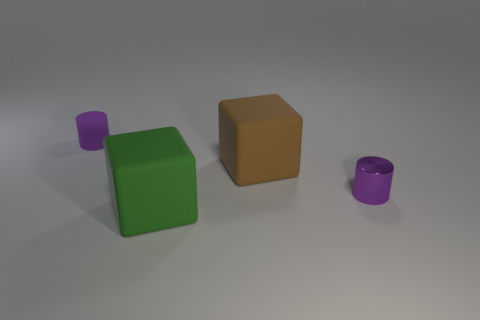Add 4 small red matte balls. How many objects exist? 8 Add 1 green rubber cubes. How many green rubber cubes exist? 2 Subtract 0 blue spheres. How many objects are left? 4 Subtract all cyan rubber things. Subtract all blocks. How many objects are left? 2 Add 4 large brown cubes. How many large brown cubes are left? 5 